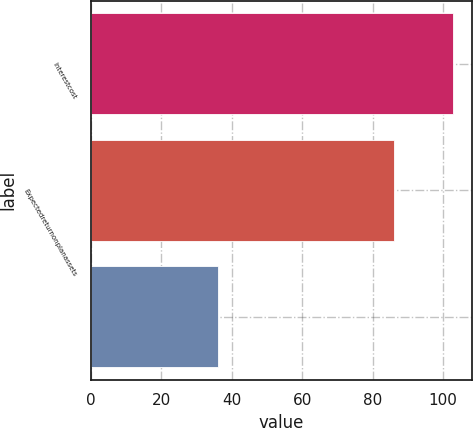Convert chart to OTSL. <chart><loc_0><loc_0><loc_500><loc_500><bar_chart><fcel>Interestcost<fcel>Expectedreturnonplanassets<fcel>Unnamed: 2<nl><fcel>103<fcel>86<fcel>36<nl></chart> 